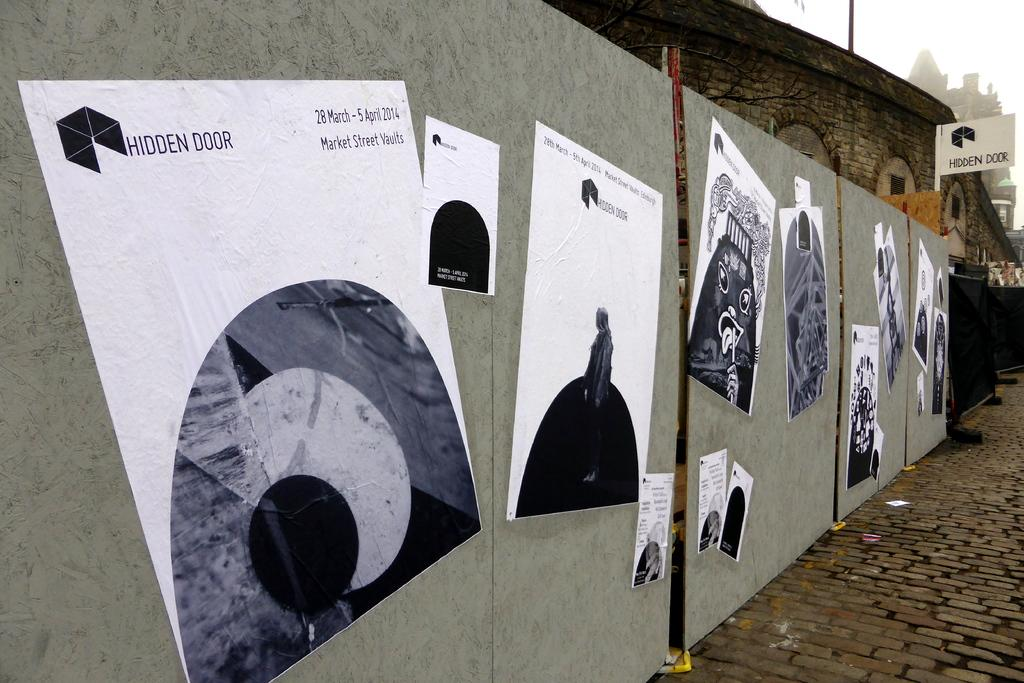What is covering the posters in the image? The posters are on a wooden sheet. What type of path can be seen in the image? The image shows a footpath. What kind of building is visible in the image? There is a stone building in the image. What structure is present in the image besides the building? A pole is present in the image. What is the color of the sky in the image? The sky is white in the image. What sound can be heard coming from the stone building in the image? There is no sound present in the image, so it is not possible to determine what sound might be coming from the building. 